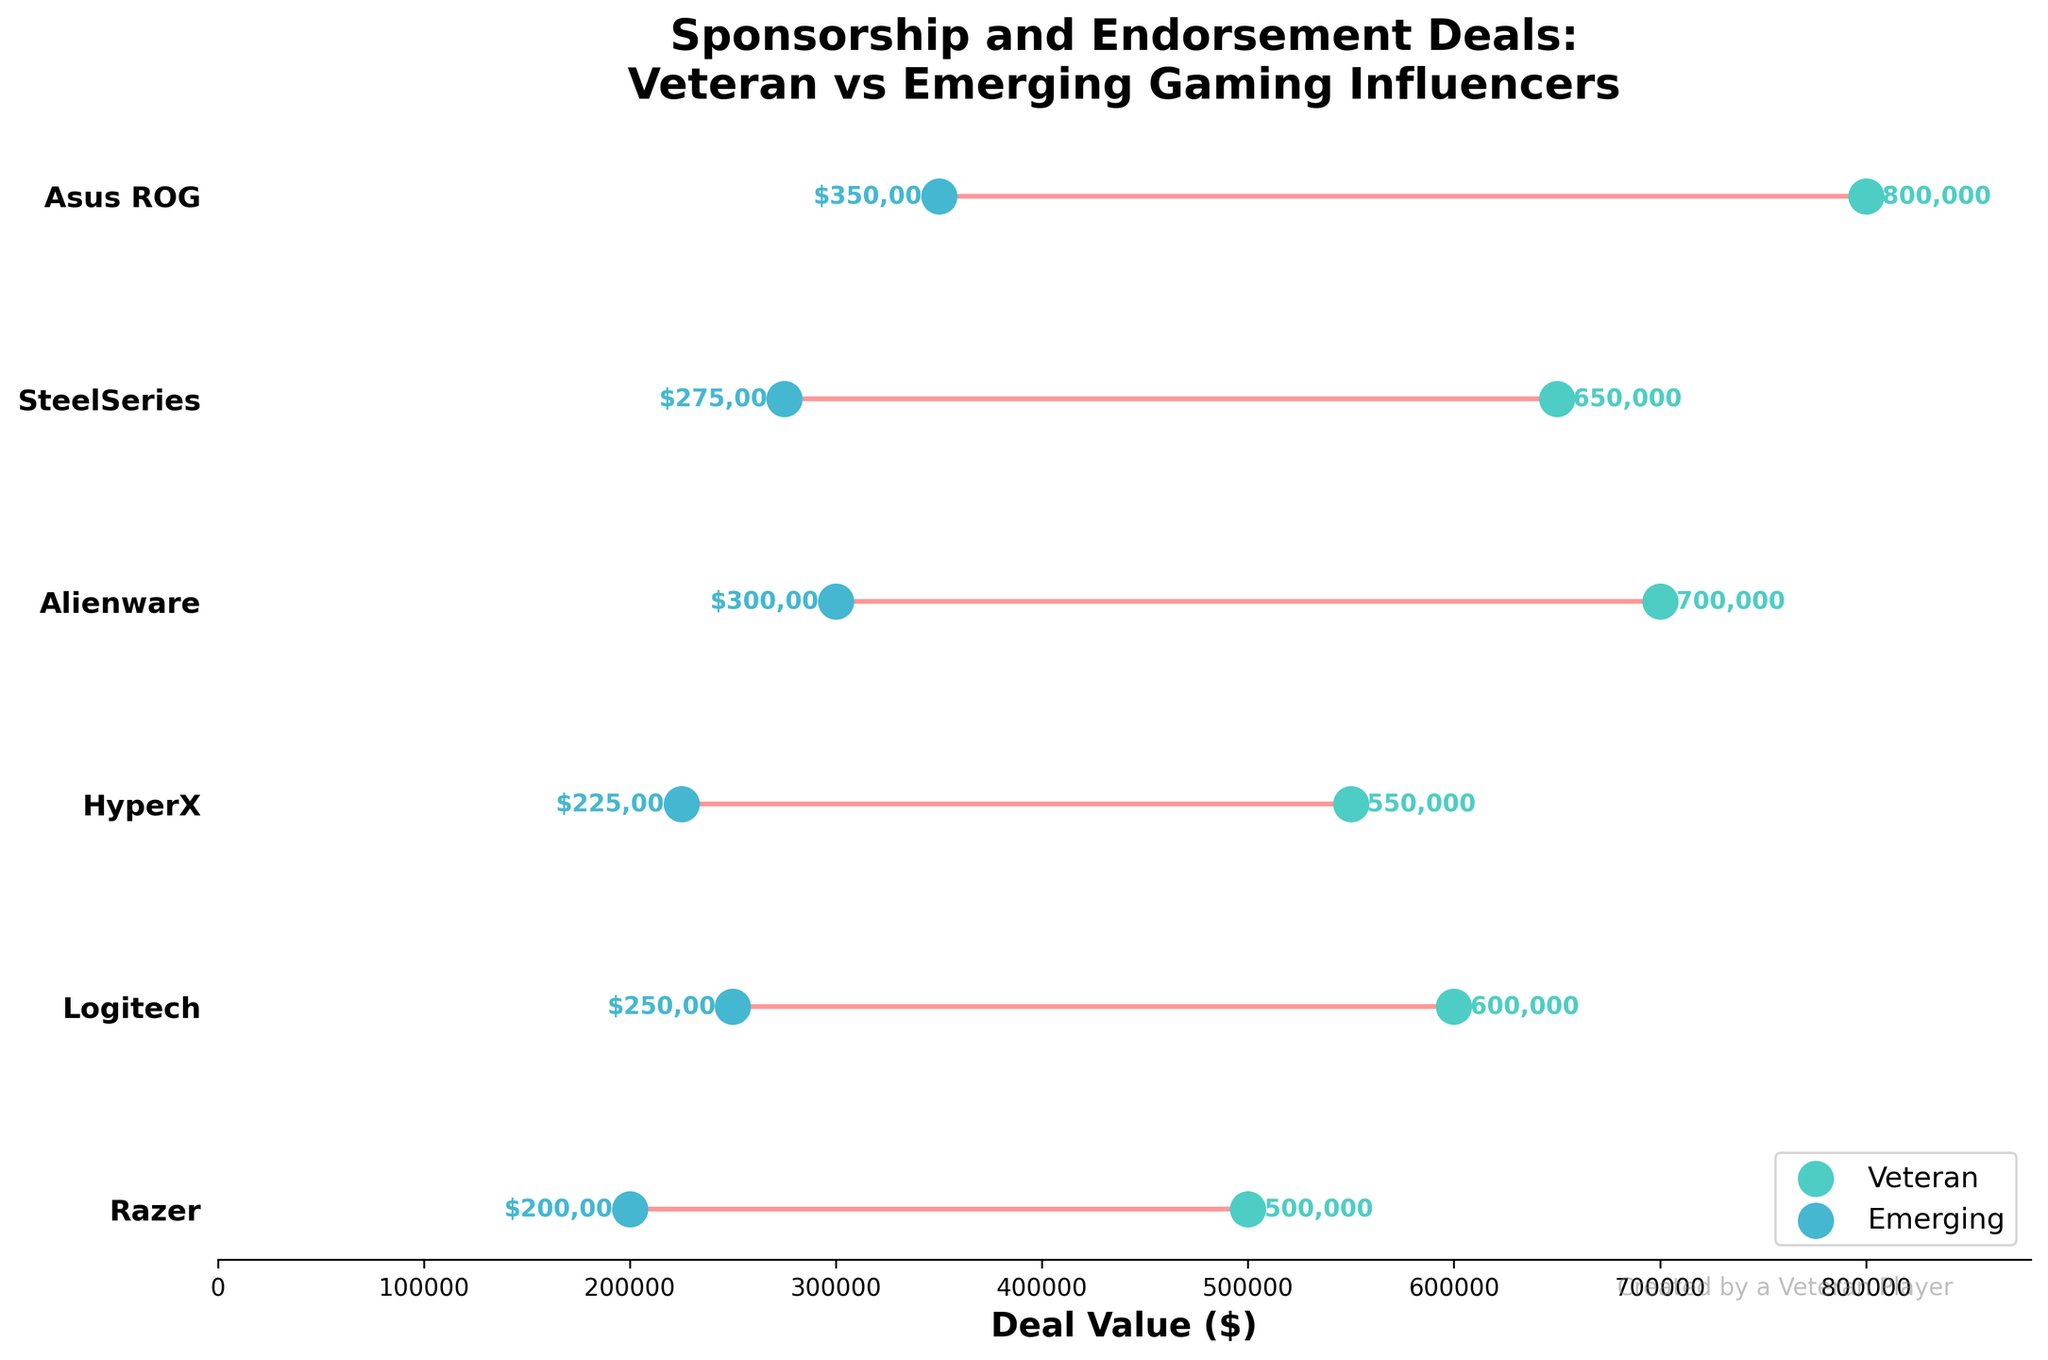What is the title of the chart? The title is located at the top of the chart, which summarizes the main idea of the chart. The title is "Sponsorship and Endorsement Deals: Veteran vs Emerging Gaming Influencers".
Answer: Sponsorship and Endorsement Deals: Veteran vs Emerging Gaming Influencers How many brands are compared in the chart? Count the number of unique brands listed on the y-axis. There are 6 unique brands listed: Razer, Logitech, HyperX, Alienware, SteelSeries, and Asus ROG.
Answer: 6 Which brand has the highest deal value for veteran influencers, and what is that value? Look at the dots colored in greenish-blue for veterans and identify the highest value. Alienware has the highest deal value for veterans at $700,000.
Answer: Alienware, $700,000 What is the difference in deal value between veterans and emerging influencers for the brand SteelSeries? Identify the deal values for SteelSeries and subtract the emerging value from the veteran value. The veteran value is $650,000, and the emerging value is $275,000. The difference is $650,000 - $275,000 = $375,000.
Answer: $375,000 Which brand has the smallest difference in deal value between veteran and emerging influencers? Calculate the difference for each brand by subtracting the emerging value from the veteran value and find the smallest difference. HyperX shows the smallest difference: $550,000 - $225,000 = $325,000.
Answer: HyperX Across all brands, what is the average deal value for emerging influencers? Sum up the deal values for all emerging influencers and divide by the number of brands. The total is $200,000 + $250,000 + $225,000 + $300,000 + $275,000 + $350,000 = $1,600,000. The average is $1,600,000 / 6 ≈ $266,667.
Answer: $266,667 How does the highest deal value for emerging influencers compare to the lowest deal value for veteran influencers? Identify the highest value for emerging influencers and the lowest value for veteran influencers and compare them. The highest value for emerging influencers is $350,000 (Asus ROG), and the lowest value for veterans is $500,000 (Razer). The veteran's lowest value is still higher.
Answer: Veteran's lowest is higher What trend does the chart show in terms of deal values between veteran and emerging influencers? Evaluate the overall direction of the lines connecting veteran and emerging values across all brands. The chart shows that veteran influencers consistently have higher deal values compared to emerging influencers.
Answer: Veterans have higher deal values What is the total combined deal value for veterans across all brands displayed? Sum up the deal values for all veteran influencers across the brands. The total is $500,000 + $600,000 + $550,000 + $700,000 + $650,000 + $800,000 = $3,800,000.
Answer: $3,800,000 Among the brands compared, which two brands show the largest gap in deal values between veteran and emerging influencers? Calculate the gap for each brand and identify the two brands with the largest gaps. The two largest gaps are Alienware ($700,000 - $300,000 = $400,000) and Asus ROG ($800,000 - $350,000 = $450,000).
Answer: Asus ROG and Alienware 